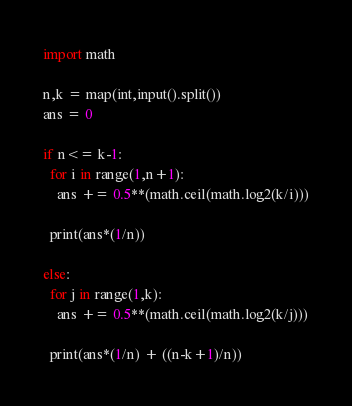Convert code to text. <code><loc_0><loc_0><loc_500><loc_500><_Python_>import math

n,k = map(int,input().split())
ans = 0 

if n<= k-1:
  for i in range(1,n+1):
    ans += 0.5**(math.ceil(math.log2(k/i)))
    
  print(ans*(1/n))
  
else:
  for j in range(1,k):
    ans += 0.5**(math.ceil(math.log2(k/j)))
    
  print(ans*(1/n) + ((n-k+1)/n))</code> 